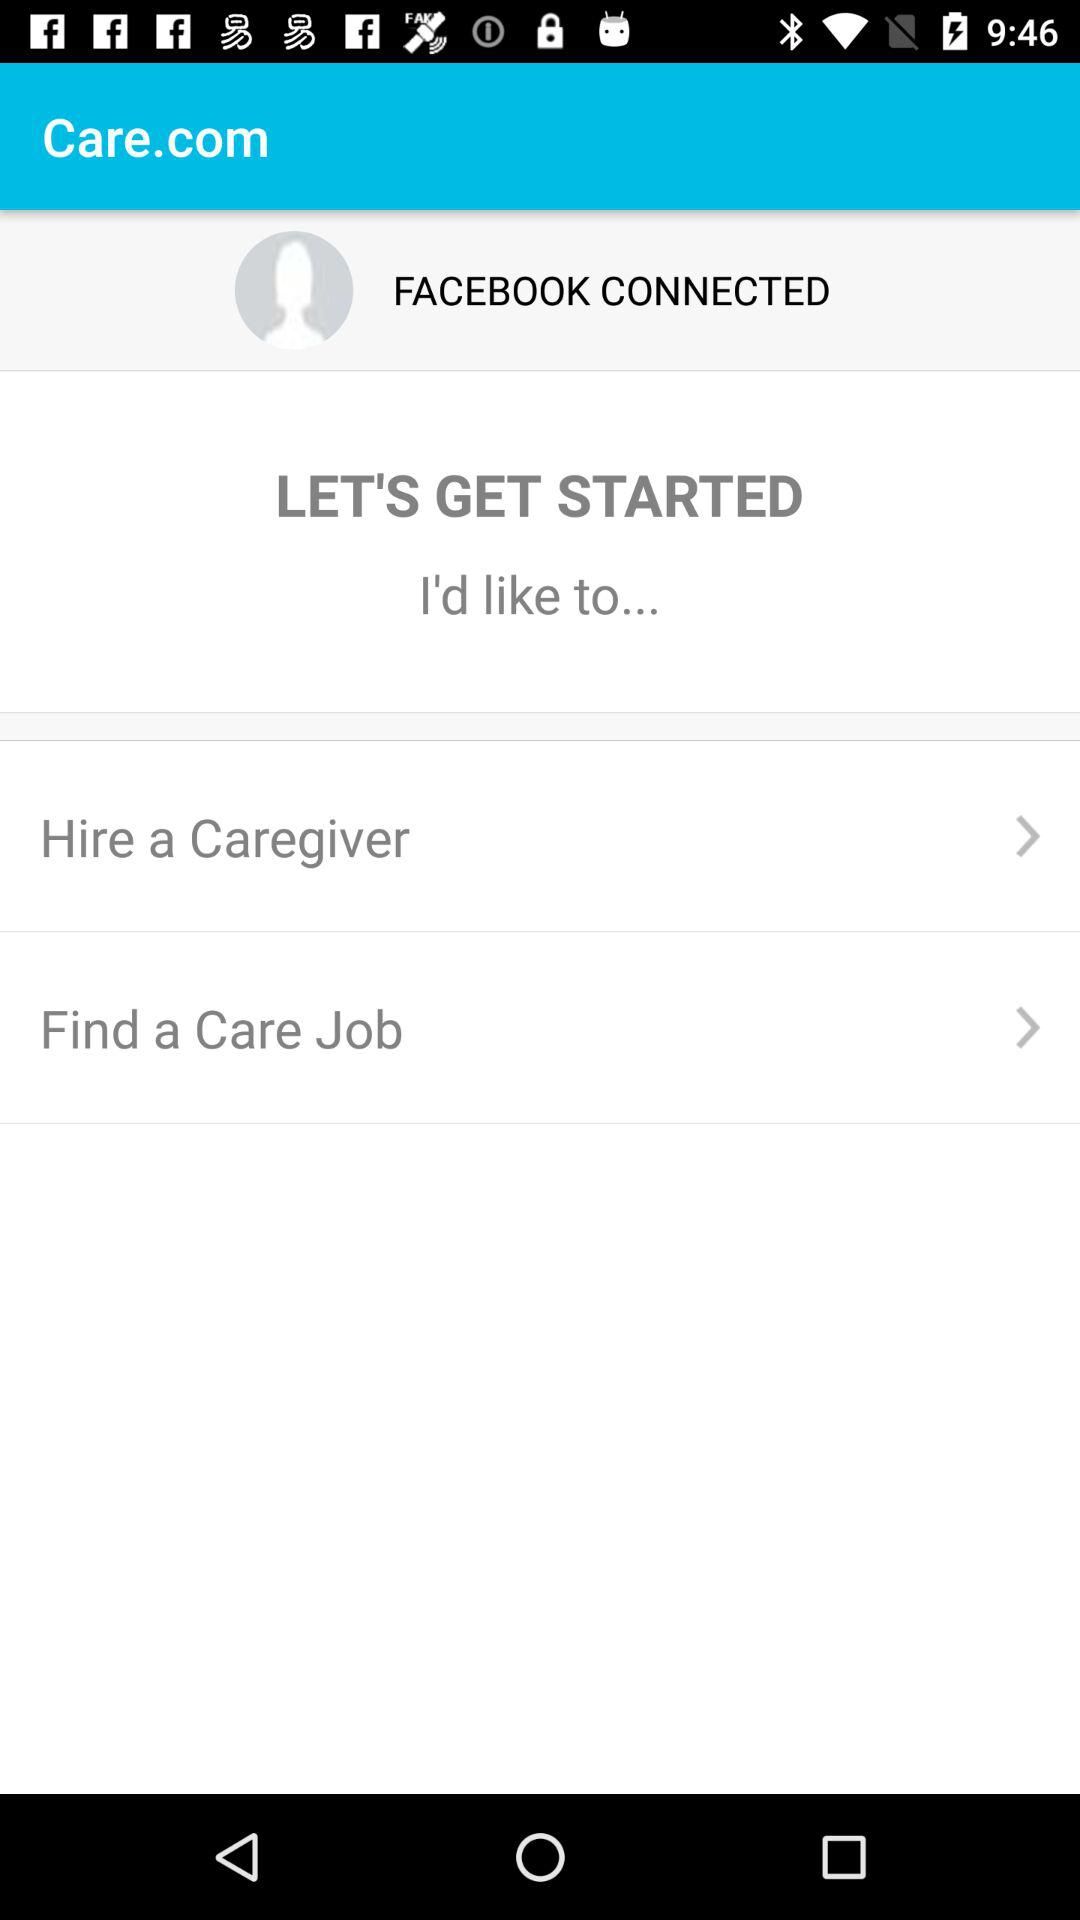Through which application do we have to connect?
When the provided information is insufficient, respond with <no answer>. <no answer> 